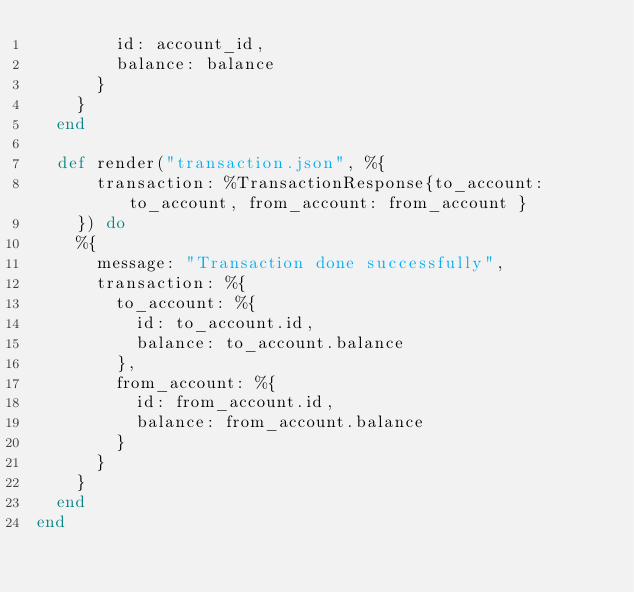Convert code to text. <code><loc_0><loc_0><loc_500><loc_500><_Elixir_>        id: account_id,
        balance: balance
      }
    }
  end

  def render("transaction.json", %{
      transaction: %TransactionResponse{to_account: to_account, from_account: from_account }
    }) do
    %{
      message: "Transaction done successfully",
      transaction: %{
        to_account: %{
          id: to_account.id,
          balance: to_account.balance
        },
        from_account: %{
          id: from_account.id,
          balance: from_account.balance
        }
      }
    }
  end
end
</code> 